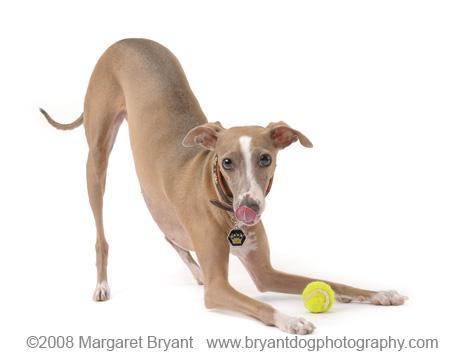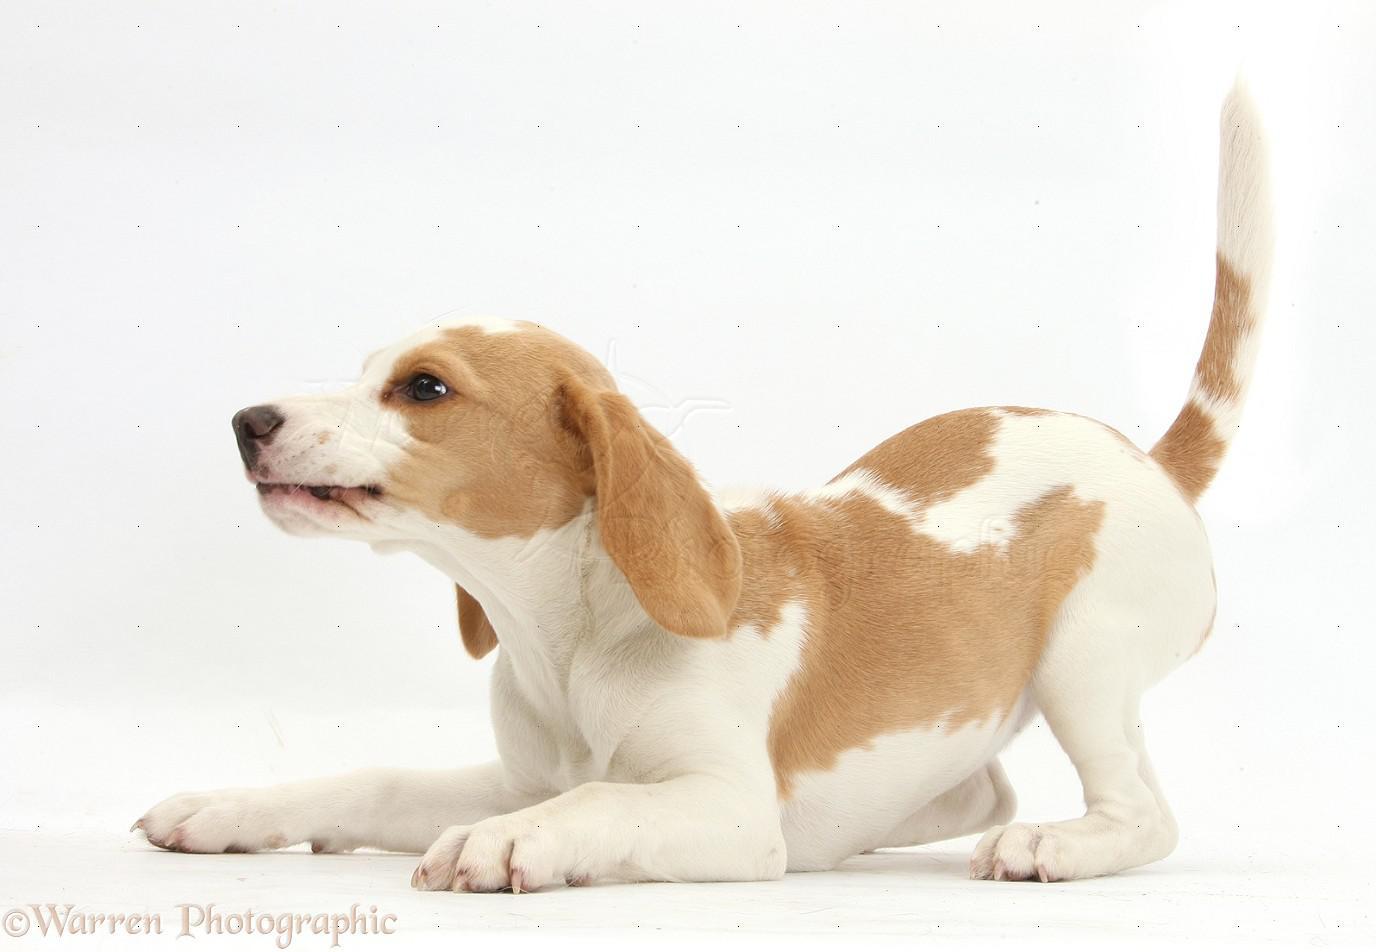The first image is the image on the left, the second image is the image on the right. Evaluate the accuracy of this statement regarding the images: "Both dogs are leaning on their front legs.". Is it true? Answer yes or no. Yes. The first image is the image on the left, the second image is the image on the right. Evaluate the accuracy of this statement regarding the images: "Each image features a hound dog posed with its front half lowered and its hind haunches raised.". Is it true? Answer yes or no. Yes. 